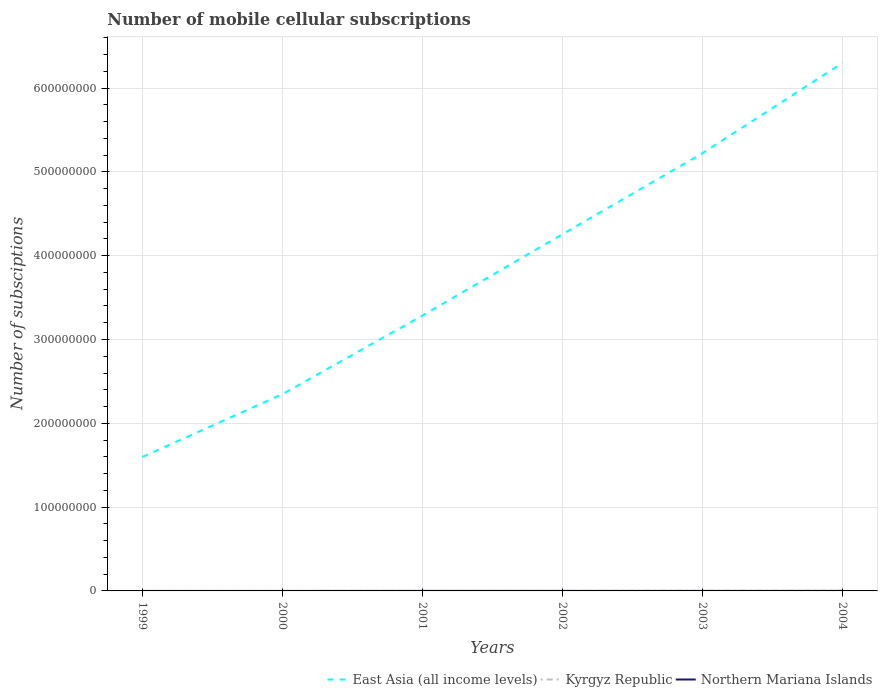How many different coloured lines are there?
Your response must be concise. 3. Across all years, what is the maximum number of mobile cellular subscriptions in Kyrgyz Republic?
Your response must be concise. 2574. In which year was the number of mobile cellular subscriptions in East Asia (all income levels) maximum?
Ensure brevity in your answer.  1999. What is the total number of mobile cellular subscriptions in East Asia (all income levels) in the graph?
Ensure brevity in your answer.  -1.08e+08. What is the difference between the highest and the second highest number of mobile cellular subscriptions in Kyrgyz Republic?
Offer a very short reply. 2.61e+05. What is the difference between the highest and the lowest number of mobile cellular subscriptions in Kyrgyz Republic?
Provide a succinct answer. 2. What is the difference between two consecutive major ticks on the Y-axis?
Your answer should be compact. 1.00e+08. Where does the legend appear in the graph?
Your answer should be compact. Bottom right. How are the legend labels stacked?
Offer a very short reply. Horizontal. What is the title of the graph?
Offer a terse response. Number of mobile cellular subscriptions. Does "Israel" appear as one of the legend labels in the graph?
Your answer should be compact. No. What is the label or title of the Y-axis?
Your response must be concise. Number of subsciptions. What is the Number of subsciptions in East Asia (all income levels) in 1999?
Offer a very short reply. 1.60e+08. What is the Number of subsciptions in Kyrgyz Republic in 1999?
Give a very brief answer. 2574. What is the Number of subsciptions in Northern Mariana Islands in 1999?
Provide a short and direct response. 2905. What is the Number of subsciptions of East Asia (all income levels) in 2000?
Provide a short and direct response. 2.35e+08. What is the Number of subsciptions of Kyrgyz Republic in 2000?
Your answer should be very brief. 9000. What is the Number of subsciptions of Northern Mariana Islands in 2000?
Give a very brief answer. 3000. What is the Number of subsciptions in East Asia (all income levels) in 2001?
Provide a succinct answer. 3.29e+08. What is the Number of subsciptions in Kyrgyz Republic in 2001?
Make the answer very short. 2.70e+04. What is the Number of subsciptions in Northern Mariana Islands in 2001?
Your response must be concise. 1.32e+04. What is the Number of subsciptions in East Asia (all income levels) in 2002?
Make the answer very short. 4.26e+08. What is the Number of subsciptions in Kyrgyz Republic in 2002?
Ensure brevity in your answer.  5.31e+04. What is the Number of subsciptions of Northern Mariana Islands in 2002?
Make the answer very short. 1.71e+04. What is the Number of subsciptions in East Asia (all income levels) in 2003?
Offer a very short reply. 5.22e+08. What is the Number of subsciptions of Kyrgyz Republic in 2003?
Your response must be concise. 1.38e+05. What is the Number of subsciptions in Northern Mariana Islands in 2003?
Offer a very short reply. 1.86e+04. What is the Number of subsciptions of East Asia (all income levels) in 2004?
Your response must be concise. 6.30e+08. What is the Number of subsciptions of Kyrgyz Republic in 2004?
Offer a terse response. 2.63e+05. What is the Number of subsciptions of Northern Mariana Islands in 2004?
Offer a terse response. 2.05e+04. Across all years, what is the maximum Number of subsciptions in East Asia (all income levels)?
Offer a very short reply. 6.30e+08. Across all years, what is the maximum Number of subsciptions in Kyrgyz Republic?
Give a very brief answer. 2.63e+05. Across all years, what is the maximum Number of subsciptions in Northern Mariana Islands?
Provide a succinct answer. 2.05e+04. Across all years, what is the minimum Number of subsciptions of East Asia (all income levels)?
Keep it short and to the point. 1.60e+08. Across all years, what is the minimum Number of subsciptions in Kyrgyz Republic?
Your answer should be compact. 2574. Across all years, what is the minimum Number of subsciptions of Northern Mariana Islands?
Ensure brevity in your answer.  2905. What is the total Number of subsciptions of East Asia (all income levels) in the graph?
Your response must be concise. 2.30e+09. What is the total Number of subsciptions in Kyrgyz Republic in the graph?
Provide a succinct answer. 4.93e+05. What is the total Number of subsciptions in Northern Mariana Islands in the graph?
Provide a succinct answer. 7.53e+04. What is the difference between the Number of subsciptions of East Asia (all income levels) in 1999 and that in 2000?
Your answer should be very brief. -7.50e+07. What is the difference between the Number of subsciptions of Kyrgyz Republic in 1999 and that in 2000?
Offer a terse response. -6426. What is the difference between the Number of subsciptions of Northern Mariana Islands in 1999 and that in 2000?
Your response must be concise. -95. What is the difference between the Number of subsciptions in East Asia (all income levels) in 1999 and that in 2001?
Make the answer very short. -1.69e+08. What is the difference between the Number of subsciptions in Kyrgyz Republic in 1999 and that in 2001?
Offer a very short reply. -2.44e+04. What is the difference between the Number of subsciptions in Northern Mariana Islands in 1999 and that in 2001?
Ensure brevity in your answer.  -1.03e+04. What is the difference between the Number of subsciptions in East Asia (all income levels) in 1999 and that in 2002?
Keep it short and to the point. -2.66e+08. What is the difference between the Number of subsciptions of Kyrgyz Republic in 1999 and that in 2002?
Make the answer very short. -5.05e+04. What is the difference between the Number of subsciptions in Northern Mariana Islands in 1999 and that in 2002?
Your answer should be compact. -1.42e+04. What is the difference between the Number of subsciptions in East Asia (all income levels) in 1999 and that in 2003?
Keep it short and to the point. -3.62e+08. What is the difference between the Number of subsciptions in Kyrgyz Republic in 1999 and that in 2003?
Your answer should be compact. -1.36e+05. What is the difference between the Number of subsciptions of Northern Mariana Islands in 1999 and that in 2003?
Ensure brevity in your answer.  -1.57e+04. What is the difference between the Number of subsciptions of East Asia (all income levels) in 1999 and that in 2004?
Provide a short and direct response. -4.70e+08. What is the difference between the Number of subsciptions of Kyrgyz Republic in 1999 and that in 2004?
Your response must be concise. -2.61e+05. What is the difference between the Number of subsciptions of Northern Mariana Islands in 1999 and that in 2004?
Provide a succinct answer. -1.76e+04. What is the difference between the Number of subsciptions in East Asia (all income levels) in 2000 and that in 2001?
Provide a short and direct response. -9.38e+07. What is the difference between the Number of subsciptions of Kyrgyz Republic in 2000 and that in 2001?
Provide a succinct answer. -1.80e+04. What is the difference between the Number of subsciptions of Northern Mariana Islands in 2000 and that in 2001?
Offer a very short reply. -1.02e+04. What is the difference between the Number of subsciptions in East Asia (all income levels) in 2000 and that in 2002?
Offer a terse response. -1.91e+08. What is the difference between the Number of subsciptions in Kyrgyz Republic in 2000 and that in 2002?
Ensure brevity in your answer.  -4.41e+04. What is the difference between the Number of subsciptions in Northern Mariana Islands in 2000 and that in 2002?
Give a very brief answer. -1.41e+04. What is the difference between the Number of subsciptions of East Asia (all income levels) in 2000 and that in 2003?
Your answer should be compact. -2.87e+08. What is the difference between the Number of subsciptions of Kyrgyz Republic in 2000 and that in 2003?
Offer a very short reply. -1.29e+05. What is the difference between the Number of subsciptions of Northern Mariana Islands in 2000 and that in 2003?
Provide a short and direct response. -1.56e+04. What is the difference between the Number of subsciptions in East Asia (all income levels) in 2000 and that in 2004?
Keep it short and to the point. -3.95e+08. What is the difference between the Number of subsciptions in Kyrgyz Republic in 2000 and that in 2004?
Make the answer very short. -2.54e+05. What is the difference between the Number of subsciptions of Northern Mariana Islands in 2000 and that in 2004?
Your answer should be very brief. -1.75e+04. What is the difference between the Number of subsciptions of East Asia (all income levels) in 2001 and that in 2002?
Make the answer very short. -9.70e+07. What is the difference between the Number of subsciptions in Kyrgyz Republic in 2001 and that in 2002?
Make the answer very short. -2.61e+04. What is the difference between the Number of subsciptions of Northern Mariana Islands in 2001 and that in 2002?
Keep it short and to the point. -3937. What is the difference between the Number of subsciptions of East Asia (all income levels) in 2001 and that in 2003?
Offer a terse response. -1.94e+08. What is the difference between the Number of subsciptions of Kyrgyz Republic in 2001 and that in 2003?
Offer a terse response. -1.11e+05. What is the difference between the Number of subsciptions in Northern Mariana Islands in 2001 and that in 2003?
Provide a succinct answer. -5419. What is the difference between the Number of subsciptions of East Asia (all income levels) in 2001 and that in 2004?
Your answer should be compact. -3.01e+08. What is the difference between the Number of subsciptions of Kyrgyz Republic in 2001 and that in 2004?
Ensure brevity in your answer.  -2.36e+05. What is the difference between the Number of subsciptions in Northern Mariana Islands in 2001 and that in 2004?
Offer a terse response. -7274. What is the difference between the Number of subsciptions of East Asia (all income levels) in 2002 and that in 2003?
Provide a succinct answer. -9.67e+07. What is the difference between the Number of subsciptions of Kyrgyz Republic in 2002 and that in 2003?
Give a very brief answer. -8.52e+04. What is the difference between the Number of subsciptions in Northern Mariana Islands in 2002 and that in 2003?
Offer a terse response. -1482. What is the difference between the Number of subsciptions in East Asia (all income levels) in 2002 and that in 2004?
Make the answer very short. -2.04e+08. What is the difference between the Number of subsciptions in Kyrgyz Republic in 2002 and that in 2004?
Make the answer very short. -2.10e+05. What is the difference between the Number of subsciptions in Northern Mariana Islands in 2002 and that in 2004?
Offer a very short reply. -3337. What is the difference between the Number of subsciptions in East Asia (all income levels) in 2003 and that in 2004?
Ensure brevity in your answer.  -1.08e+08. What is the difference between the Number of subsciptions in Kyrgyz Republic in 2003 and that in 2004?
Provide a short and direct response. -1.25e+05. What is the difference between the Number of subsciptions of Northern Mariana Islands in 2003 and that in 2004?
Your answer should be compact. -1855. What is the difference between the Number of subsciptions of East Asia (all income levels) in 1999 and the Number of subsciptions of Kyrgyz Republic in 2000?
Keep it short and to the point. 1.60e+08. What is the difference between the Number of subsciptions in East Asia (all income levels) in 1999 and the Number of subsciptions in Northern Mariana Islands in 2000?
Keep it short and to the point. 1.60e+08. What is the difference between the Number of subsciptions of Kyrgyz Republic in 1999 and the Number of subsciptions of Northern Mariana Islands in 2000?
Your response must be concise. -426. What is the difference between the Number of subsciptions of East Asia (all income levels) in 1999 and the Number of subsciptions of Kyrgyz Republic in 2001?
Your answer should be compact. 1.60e+08. What is the difference between the Number of subsciptions in East Asia (all income levels) in 1999 and the Number of subsciptions in Northern Mariana Islands in 2001?
Give a very brief answer. 1.60e+08. What is the difference between the Number of subsciptions in Kyrgyz Republic in 1999 and the Number of subsciptions in Northern Mariana Islands in 2001?
Ensure brevity in your answer.  -1.06e+04. What is the difference between the Number of subsciptions in East Asia (all income levels) in 1999 and the Number of subsciptions in Kyrgyz Republic in 2002?
Give a very brief answer. 1.60e+08. What is the difference between the Number of subsciptions of East Asia (all income levels) in 1999 and the Number of subsciptions of Northern Mariana Islands in 2002?
Give a very brief answer. 1.60e+08. What is the difference between the Number of subsciptions in Kyrgyz Republic in 1999 and the Number of subsciptions in Northern Mariana Islands in 2002?
Offer a very short reply. -1.46e+04. What is the difference between the Number of subsciptions of East Asia (all income levels) in 1999 and the Number of subsciptions of Kyrgyz Republic in 2003?
Your answer should be compact. 1.60e+08. What is the difference between the Number of subsciptions of East Asia (all income levels) in 1999 and the Number of subsciptions of Northern Mariana Islands in 2003?
Your answer should be very brief. 1.60e+08. What is the difference between the Number of subsciptions of Kyrgyz Republic in 1999 and the Number of subsciptions of Northern Mariana Islands in 2003?
Your answer should be very brief. -1.60e+04. What is the difference between the Number of subsciptions in East Asia (all income levels) in 1999 and the Number of subsciptions in Kyrgyz Republic in 2004?
Offer a terse response. 1.60e+08. What is the difference between the Number of subsciptions of East Asia (all income levels) in 1999 and the Number of subsciptions of Northern Mariana Islands in 2004?
Your answer should be very brief. 1.60e+08. What is the difference between the Number of subsciptions in Kyrgyz Republic in 1999 and the Number of subsciptions in Northern Mariana Islands in 2004?
Ensure brevity in your answer.  -1.79e+04. What is the difference between the Number of subsciptions in East Asia (all income levels) in 2000 and the Number of subsciptions in Kyrgyz Republic in 2001?
Make the answer very short. 2.35e+08. What is the difference between the Number of subsciptions in East Asia (all income levels) in 2000 and the Number of subsciptions in Northern Mariana Islands in 2001?
Keep it short and to the point. 2.35e+08. What is the difference between the Number of subsciptions in Kyrgyz Republic in 2000 and the Number of subsciptions in Northern Mariana Islands in 2001?
Provide a short and direct response. -4200. What is the difference between the Number of subsciptions in East Asia (all income levels) in 2000 and the Number of subsciptions in Kyrgyz Republic in 2002?
Give a very brief answer. 2.35e+08. What is the difference between the Number of subsciptions of East Asia (all income levels) in 2000 and the Number of subsciptions of Northern Mariana Islands in 2002?
Your answer should be compact. 2.35e+08. What is the difference between the Number of subsciptions of Kyrgyz Republic in 2000 and the Number of subsciptions of Northern Mariana Islands in 2002?
Provide a short and direct response. -8137. What is the difference between the Number of subsciptions in East Asia (all income levels) in 2000 and the Number of subsciptions in Kyrgyz Republic in 2003?
Make the answer very short. 2.35e+08. What is the difference between the Number of subsciptions of East Asia (all income levels) in 2000 and the Number of subsciptions of Northern Mariana Islands in 2003?
Your answer should be very brief. 2.35e+08. What is the difference between the Number of subsciptions of Kyrgyz Republic in 2000 and the Number of subsciptions of Northern Mariana Islands in 2003?
Offer a terse response. -9619. What is the difference between the Number of subsciptions of East Asia (all income levels) in 2000 and the Number of subsciptions of Kyrgyz Republic in 2004?
Offer a very short reply. 2.35e+08. What is the difference between the Number of subsciptions in East Asia (all income levels) in 2000 and the Number of subsciptions in Northern Mariana Islands in 2004?
Provide a succinct answer. 2.35e+08. What is the difference between the Number of subsciptions of Kyrgyz Republic in 2000 and the Number of subsciptions of Northern Mariana Islands in 2004?
Your answer should be compact. -1.15e+04. What is the difference between the Number of subsciptions in East Asia (all income levels) in 2001 and the Number of subsciptions in Kyrgyz Republic in 2002?
Give a very brief answer. 3.29e+08. What is the difference between the Number of subsciptions in East Asia (all income levels) in 2001 and the Number of subsciptions in Northern Mariana Islands in 2002?
Your response must be concise. 3.29e+08. What is the difference between the Number of subsciptions in Kyrgyz Republic in 2001 and the Number of subsciptions in Northern Mariana Islands in 2002?
Offer a terse response. 9863. What is the difference between the Number of subsciptions in East Asia (all income levels) in 2001 and the Number of subsciptions in Kyrgyz Republic in 2003?
Offer a terse response. 3.28e+08. What is the difference between the Number of subsciptions of East Asia (all income levels) in 2001 and the Number of subsciptions of Northern Mariana Islands in 2003?
Provide a short and direct response. 3.29e+08. What is the difference between the Number of subsciptions in Kyrgyz Republic in 2001 and the Number of subsciptions in Northern Mariana Islands in 2003?
Keep it short and to the point. 8381. What is the difference between the Number of subsciptions in East Asia (all income levels) in 2001 and the Number of subsciptions in Kyrgyz Republic in 2004?
Your answer should be very brief. 3.28e+08. What is the difference between the Number of subsciptions in East Asia (all income levels) in 2001 and the Number of subsciptions in Northern Mariana Islands in 2004?
Provide a short and direct response. 3.29e+08. What is the difference between the Number of subsciptions of Kyrgyz Republic in 2001 and the Number of subsciptions of Northern Mariana Islands in 2004?
Keep it short and to the point. 6526. What is the difference between the Number of subsciptions in East Asia (all income levels) in 2002 and the Number of subsciptions in Kyrgyz Republic in 2003?
Offer a terse response. 4.26e+08. What is the difference between the Number of subsciptions of East Asia (all income levels) in 2002 and the Number of subsciptions of Northern Mariana Islands in 2003?
Make the answer very short. 4.26e+08. What is the difference between the Number of subsciptions of Kyrgyz Republic in 2002 and the Number of subsciptions of Northern Mariana Islands in 2003?
Your response must be concise. 3.45e+04. What is the difference between the Number of subsciptions of East Asia (all income levels) in 2002 and the Number of subsciptions of Kyrgyz Republic in 2004?
Offer a terse response. 4.25e+08. What is the difference between the Number of subsciptions in East Asia (all income levels) in 2002 and the Number of subsciptions in Northern Mariana Islands in 2004?
Offer a very short reply. 4.26e+08. What is the difference between the Number of subsciptions in Kyrgyz Republic in 2002 and the Number of subsciptions in Northern Mariana Islands in 2004?
Keep it short and to the point. 3.26e+04. What is the difference between the Number of subsciptions in East Asia (all income levels) in 2003 and the Number of subsciptions in Kyrgyz Republic in 2004?
Provide a succinct answer. 5.22e+08. What is the difference between the Number of subsciptions of East Asia (all income levels) in 2003 and the Number of subsciptions of Northern Mariana Islands in 2004?
Your response must be concise. 5.22e+08. What is the difference between the Number of subsciptions of Kyrgyz Republic in 2003 and the Number of subsciptions of Northern Mariana Islands in 2004?
Make the answer very short. 1.18e+05. What is the average Number of subsciptions in East Asia (all income levels) per year?
Give a very brief answer. 3.84e+08. What is the average Number of subsciptions of Kyrgyz Republic per year?
Your answer should be compact. 8.22e+04. What is the average Number of subsciptions of Northern Mariana Islands per year?
Provide a succinct answer. 1.26e+04. In the year 1999, what is the difference between the Number of subsciptions in East Asia (all income levels) and Number of subsciptions in Kyrgyz Republic?
Offer a very short reply. 1.60e+08. In the year 1999, what is the difference between the Number of subsciptions of East Asia (all income levels) and Number of subsciptions of Northern Mariana Islands?
Keep it short and to the point. 1.60e+08. In the year 1999, what is the difference between the Number of subsciptions in Kyrgyz Republic and Number of subsciptions in Northern Mariana Islands?
Offer a terse response. -331. In the year 2000, what is the difference between the Number of subsciptions in East Asia (all income levels) and Number of subsciptions in Kyrgyz Republic?
Make the answer very short. 2.35e+08. In the year 2000, what is the difference between the Number of subsciptions of East Asia (all income levels) and Number of subsciptions of Northern Mariana Islands?
Your response must be concise. 2.35e+08. In the year 2000, what is the difference between the Number of subsciptions of Kyrgyz Republic and Number of subsciptions of Northern Mariana Islands?
Keep it short and to the point. 6000. In the year 2001, what is the difference between the Number of subsciptions of East Asia (all income levels) and Number of subsciptions of Kyrgyz Republic?
Ensure brevity in your answer.  3.29e+08. In the year 2001, what is the difference between the Number of subsciptions of East Asia (all income levels) and Number of subsciptions of Northern Mariana Islands?
Your answer should be compact. 3.29e+08. In the year 2001, what is the difference between the Number of subsciptions of Kyrgyz Republic and Number of subsciptions of Northern Mariana Islands?
Your answer should be very brief. 1.38e+04. In the year 2002, what is the difference between the Number of subsciptions in East Asia (all income levels) and Number of subsciptions in Kyrgyz Republic?
Provide a short and direct response. 4.26e+08. In the year 2002, what is the difference between the Number of subsciptions in East Asia (all income levels) and Number of subsciptions in Northern Mariana Islands?
Give a very brief answer. 4.26e+08. In the year 2002, what is the difference between the Number of subsciptions in Kyrgyz Republic and Number of subsciptions in Northern Mariana Islands?
Your response must be concise. 3.59e+04. In the year 2003, what is the difference between the Number of subsciptions of East Asia (all income levels) and Number of subsciptions of Kyrgyz Republic?
Ensure brevity in your answer.  5.22e+08. In the year 2003, what is the difference between the Number of subsciptions in East Asia (all income levels) and Number of subsciptions in Northern Mariana Islands?
Your answer should be compact. 5.22e+08. In the year 2003, what is the difference between the Number of subsciptions in Kyrgyz Republic and Number of subsciptions in Northern Mariana Islands?
Provide a short and direct response. 1.20e+05. In the year 2004, what is the difference between the Number of subsciptions in East Asia (all income levels) and Number of subsciptions in Kyrgyz Republic?
Your answer should be compact. 6.30e+08. In the year 2004, what is the difference between the Number of subsciptions of East Asia (all income levels) and Number of subsciptions of Northern Mariana Islands?
Your response must be concise. 6.30e+08. In the year 2004, what is the difference between the Number of subsciptions in Kyrgyz Republic and Number of subsciptions in Northern Mariana Islands?
Your response must be concise. 2.43e+05. What is the ratio of the Number of subsciptions in East Asia (all income levels) in 1999 to that in 2000?
Your answer should be very brief. 0.68. What is the ratio of the Number of subsciptions of Kyrgyz Republic in 1999 to that in 2000?
Provide a succinct answer. 0.29. What is the ratio of the Number of subsciptions of Northern Mariana Islands in 1999 to that in 2000?
Make the answer very short. 0.97. What is the ratio of the Number of subsciptions in East Asia (all income levels) in 1999 to that in 2001?
Give a very brief answer. 0.49. What is the ratio of the Number of subsciptions in Kyrgyz Republic in 1999 to that in 2001?
Keep it short and to the point. 0.1. What is the ratio of the Number of subsciptions of Northern Mariana Islands in 1999 to that in 2001?
Keep it short and to the point. 0.22. What is the ratio of the Number of subsciptions of East Asia (all income levels) in 1999 to that in 2002?
Provide a succinct answer. 0.38. What is the ratio of the Number of subsciptions of Kyrgyz Republic in 1999 to that in 2002?
Keep it short and to the point. 0.05. What is the ratio of the Number of subsciptions of Northern Mariana Islands in 1999 to that in 2002?
Your response must be concise. 0.17. What is the ratio of the Number of subsciptions in East Asia (all income levels) in 1999 to that in 2003?
Offer a very short reply. 0.31. What is the ratio of the Number of subsciptions in Kyrgyz Republic in 1999 to that in 2003?
Your answer should be very brief. 0.02. What is the ratio of the Number of subsciptions in Northern Mariana Islands in 1999 to that in 2003?
Your answer should be very brief. 0.16. What is the ratio of the Number of subsciptions of East Asia (all income levels) in 1999 to that in 2004?
Provide a succinct answer. 0.25. What is the ratio of the Number of subsciptions in Kyrgyz Republic in 1999 to that in 2004?
Offer a terse response. 0.01. What is the ratio of the Number of subsciptions of Northern Mariana Islands in 1999 to that in 2004?
Ensure brevity in your answer.  0.14. What is the ratio of the Number of subsciptions of East Asia (all income levels) in 2000 to that in 2001?
Your answer should be very brief. 0.71. What is the ratio of the Number of subsciptions of Northern Mariana Islands in 2000 to that in 2001?
Make the answer very short. 0.23. What is the ratio of the Number of subsciptions of East Asia (all income levels) in 2000 to that in 2002?
Offer a terse response. 0.55. What is the ratio of the Number of subsciptions of Kyrgyz Republic in 2000 to that in 2002?
Your answer should be very brief. 0.17. What is the ratio of the Number of subsciptions in Northern Mariana Islands in 2000 to that in 2002?
Ensure brevity in your answer.  0.18. What is the ratio of the Number of subsciptions in East Asia (all income levels) in 2000 to that in 2003?
Provide a succinct answer. 0.45. What is the ratio of the Number of subsciptions of Kyrgyz Republic in 2000 to that in 2003?
Make the answer very short. 0.07. What is the ratio of the Number of subsciptions in Northern Mariana Islands in 2000 to that in 2003?
Provide a short and direct response. 0.16. What is the ratio of the Number of subsciptions of East Asia (all income levels) in 2000 to that in 2004?
Make the answer very short. 0.37. What is the ratio of the Number of subsciptions in Kyrgyz Republic in 2000 to that in 2004?
Make the answer very short. 0.03. What is the ratio of the Number of subsciptions of Northern Mariana Islands in 2000 to that in 2004?
Give a very brief answer. 0.15. What is the ratio of the Number of subsciptions of East Asia (all income levels) in 2001 to that in 2002?
Offer a very short reply. 0.77. What is the ratio of the Number of subsciptions in Kyrgyz Republic in 2001 to that in 2002?
Provide a succinct answer. 0.51. What is the ratio of the Number of subsciptions of Northern Mariana Islands in 2001 to that in 2002?
Keep it short and to the point. 0.77. What is the ratio of the Number of subsciptions in East Asia (all income levels) in 2001 to that in 2003?
Ensure brevity in your answer.  0.63. What is the ratio of the Number of subsciptions in Kyrgyz Republic in 2001 to that in 2003?
Provide a short and direct response. 0.2. What is the ratio of the Number of subsciptions of Northern Mariana Islands in 2001 to that in 2003?
Ensure brevity in your answer.  0.71. What is the ratio of the Number of subsciptions of East Asia (all income levels) in 2001 to that in 2004?
Give a very brief answer. 0.52. What is the ratio of the Number of subsciptions in Kyrgyz Republic in 2001 to that in 2004?
Your response must be concise. 0.1. What is the ratio of the Number of subsciptions in Northern Mariana Islands in 2001 to that in 2004?
Ensure brevity in your answer.  0.64. What is the ratio of the Number of subsciptions of East Asia (all income levels) in 2002 to that in 2003?
Offer a terse response. 0.81. What is the ratio of the Number of subsciptions in Kyrgyz Republic in 2002 to that in 2003?
Your answer should be compact. 0.38. What is the ratio of the Number of subsciptions in Northern Mariana Islands in 2002 to that in 2003?
Your response must be concise. 0.92. What is the ratio of the Number of subsciptions in East Asia (all income levels) in 2002 to that in 2004?
Your response must be concise. 0.68. What is the ratio of the Number of subsciptions of Kyrgyz Republic in 2002 to that in 2004?
Provide a short and direct response. 0.2. What is the ratio of the Number of subsciptions in Northern Mariana Islands in 2002 to that in 2004?
Your answer should be very brief. 0.84. What is the ratio of the Number of subsciptions in East Asia (all income levels) in 2003 to that in 2004?
Offer a very short reply. 0.83. What is the ratio of the Number of subsciptions in Kyrgyz Republic in 2003 to that in 2004?
Give a very brief answer. 0.53. What is the ratio of the Number of subsciptions of Northern Mariana Islands in 2003 to that in 2004?
Give a very brief answer. 0.91. What is the difference between the highest and the second highest Number of subsciptions of East Asia (all income levels)?
Give a very brief answer. 1.08e+08. What is the difference between the highest and the second highest Number of subsciptions in Kyrgyz Republic?
Your answer should be very brief. 1.25e+05. What is the difference between the highest and the second highest Number of subsciptions in Northern Mariana Islands?
Your answer should be compact. 1855. What is the difference between the highest and the lowest Number of subsciptions in East Asia (all income levels)?
Provide a succinct answer. 4.70e+08. What is the difference between the highest and the lowest Number of subsciptions in Kyrgyz Republic?
Keep it short and to the point. 2.61e+05. What is the difference between the highest and the lowest Number of subsciptions in Northern Mariana Islands?
Your response must be concise. 1.76e+04. 